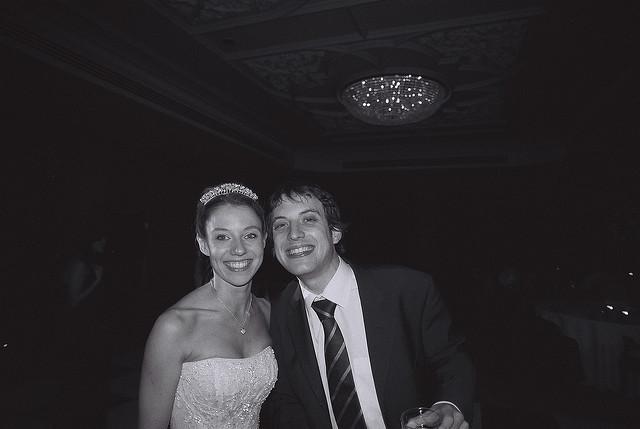What is the woman wearing around her neck?
Be succinct. Necklace. Is this woman smiling?
Answer briefly. Yes. What event is this?
Short answer required. Wedding. Are these people dressed in expensive clothes?
Answer briefly. Yes. What color is the tie the boy is sporting?
Be succinct. Black. Do these 2 individuals look happy?
Answer briefly. Yes. Does she look happy?
Be succinct. Yes. Is the girl carrying a purse?
Keep it brief. No. What is on her head?
Be succinct. Tiara. 